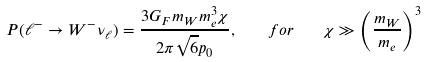<formula> <loc_0><loc_0><loc_500><loc_500>P ( \ell ^ { - } \rightarrow W ^ { - } \nu _ { \ell } ) = \frac { 3 G _ { F } m _ { W } m _ { e } ^ { 3 } \chi } { 2 \pi \sqrt { 6 } p _ { 0 } } , \quad f o r \quad \chi \gg \left ( { \frac { m _ { W } } { m _ { e } } } \right ) ^ { 3 }</formula> 